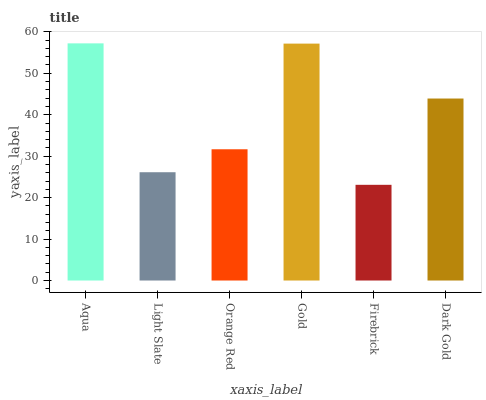Is Firebrick the minimum?
Answer yes or no. Yes. Is Aqua the maximum?
Answer yes or no. Yes. Is Light Slate the minimum?
Answer yes or no. No. Is Light Slate the maximum?
Answer yes or no. No. Is Aqua greater than Light Slate?
Answer yes or no. Yes. Is Light Slate less than Aqua?
Answer yes or no. Yes. Is Light Slate greater than Aqua?
Answer yes or no. No. Is Aqua less than Light Slate?
Answer yes or no. No. Is Dark Gold the high median?
Answer yes or no. Yes. Is Orange Red the low median?
Answer yes or no. Yes. Is Gold the high median?
Answer yes or no. No. Is Aqua the low median?
Answer yes or no. No. 